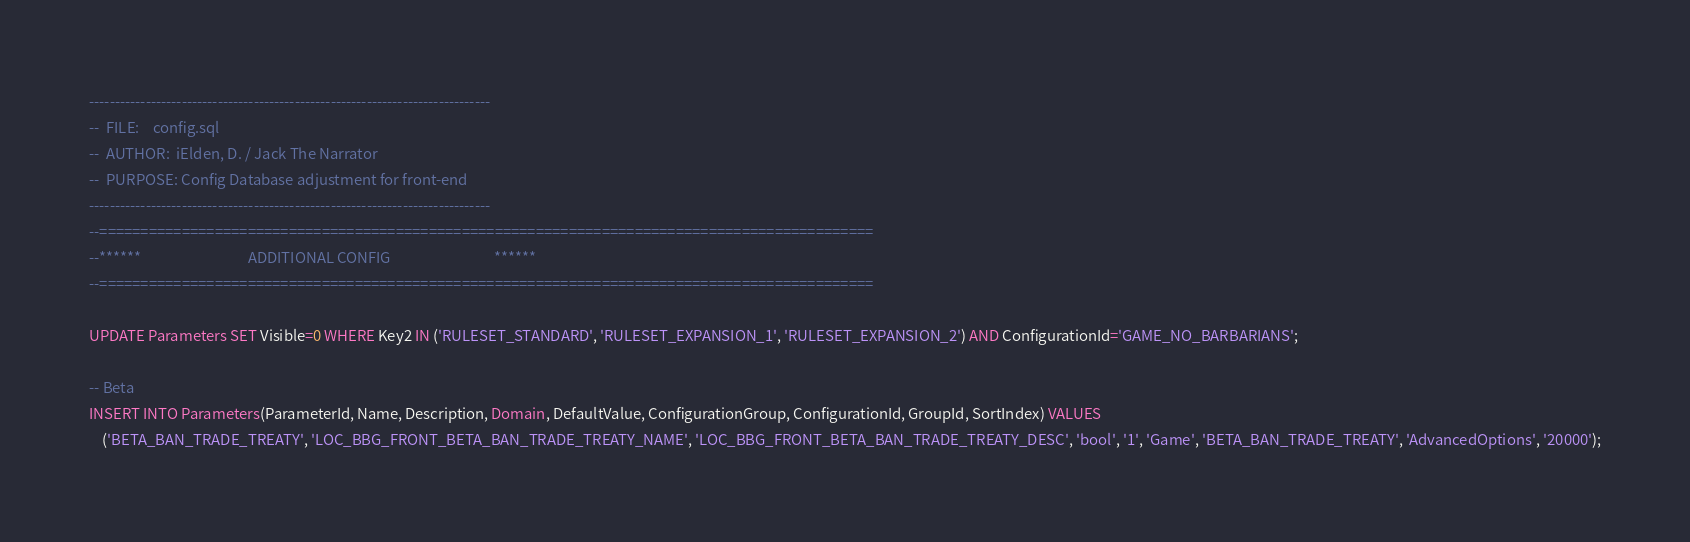<code> <loc_0><loc_0><loc_500><loc_500><_SQL_>------------------------------------------------------------------------------
--	FILE:	 config.sql
--	AUTHOR:  iElden, D. / Jack The Narrator
--	PURPOSE: Config Database adjustment for front-end
------------------------------------------------------------------------------
--==============================================================================================
--******								ADDITIONAL CONFIG								******
--==============================================================================================

UPDATE Parameters SET Visible=0 WHERE Key2 IN ('RULESET_STANDARD', 'RULESET_EXPANSION_1', 'RULESET_EXPANSION_2') AND ConfigurationId='GAME_NO_BARBARIANS';

-- Beta
INSERT INTO Parameters(ParameterId, Name, Description, Domain, DefaultValue, ConfigurationGroup, ConfigurationId, GroupId, SortIndex) VALUES
    ('BETA_BAN_TRADE_TREATY', 'LOC_BBG_FRONT_BETA_BAN_TRADE_TREATY_NAME', 'LOC_BBG_FRONT_BETA_BAN_TRADE_TREATY_DESC', 'bool', '1', 'Game', 'BETA_BAN_TRADE_TREATY', 'AdvancedOptions', '20000');
</code> 